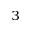<formula> <loc_0><loc_0><loc_500><loc_500>^ { 3 }</formula> 